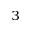<formula> <loc_0><loc_0><loc_500><loc_500>^ { 3 }</formula> 